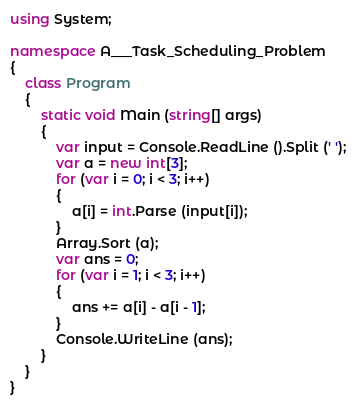Convert code to text. <code><loc_0><loc_0><loc_500><loc_500><_C#_>using System;

namespace A___Task_Scheduling_Problem
{
    class Program
    {
        static void Main (string[] args)
        {
            var input = Console.ReadLine ().Split (' ');
            var a = new int[3];
            for (var i = 0; i < 3; i++)
            {
                a[i] = int.Parse (input[i]);
            }
            Array.Sort (a);
            var ans = 0;
            for (var i = 1; i < 3; i++)
            {
                ans += a[i] - a[i - 1];
            }
            Console.WriteLine (ans);
        }
    }
}</code> 